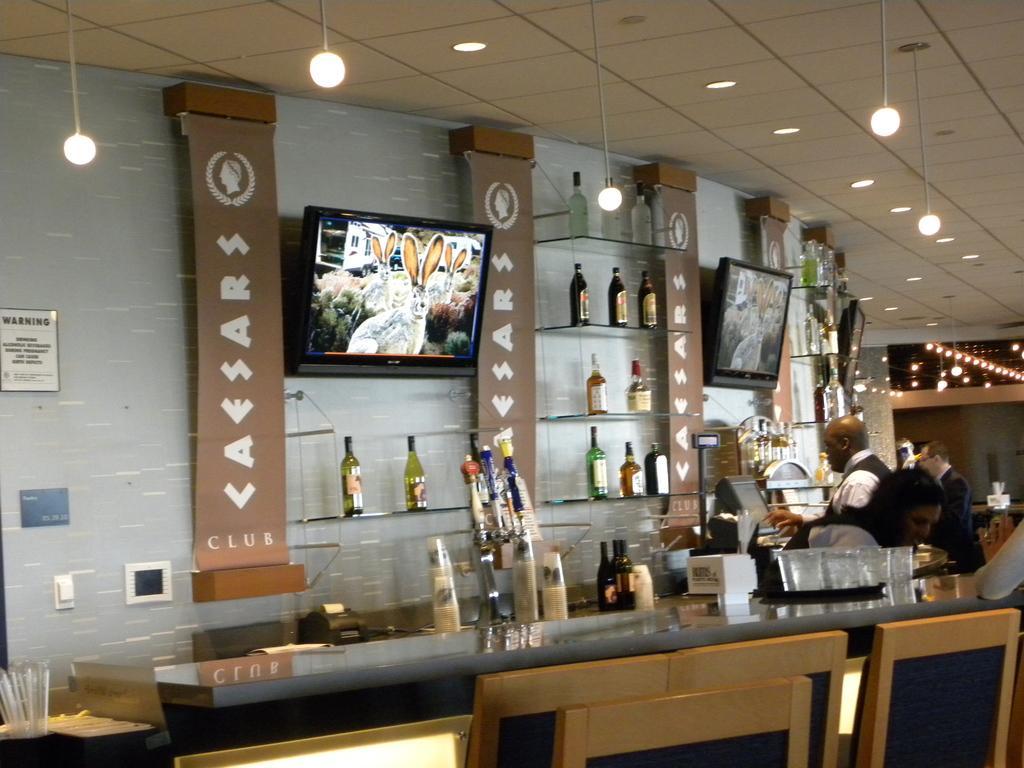In one or two sentences, can you explain what this image depicts? This is an inside view. Here I can see a table in which few glasses are placed. Beside the table there are some chairs. On the right side, I can see few people. In the background, I can see few bottles in the racks and two monitors are attached to the wall. At the top I can see few lights. 